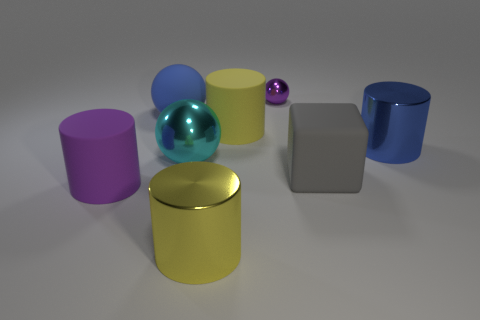Do the small thing and the matte thing left of the matte ball have the same color?
Give a very brief answer. Yes. Are there any big cylinders that have the same color as the big matte sphere?
Your response must be concise. Yes. What material is the yellow cylinder that is in front of the cube?
Your answer should be very brief. Metal. Are there any yellow things in front of the large blue cylinder?
Offer a very short reply. Yes. Is the rubber ball the same size as the purple ball?
Your answer should be very brief. No. What number of large gray cubes are the same material as the large cyan ball?
Make the answer very short. 0. There is a matte cylinder behind the big blue metal cylinder that is behind the yellow metal thing; how big is it?
Your answer should be very brief. Large. There is a big metal thing that is both behind the gray matte cube and on the left side of the large blue metal cylinder; what is its color?
Make the answer very short. Cyan. Is the shape of the small purple thing the same as the big cyan thing?
Offer a very short reply. Yes. The blue thing that is on the left side of the blue shiny thing that is on the right side of the block is what shape?
Keep it short and to the point. Sphere. 